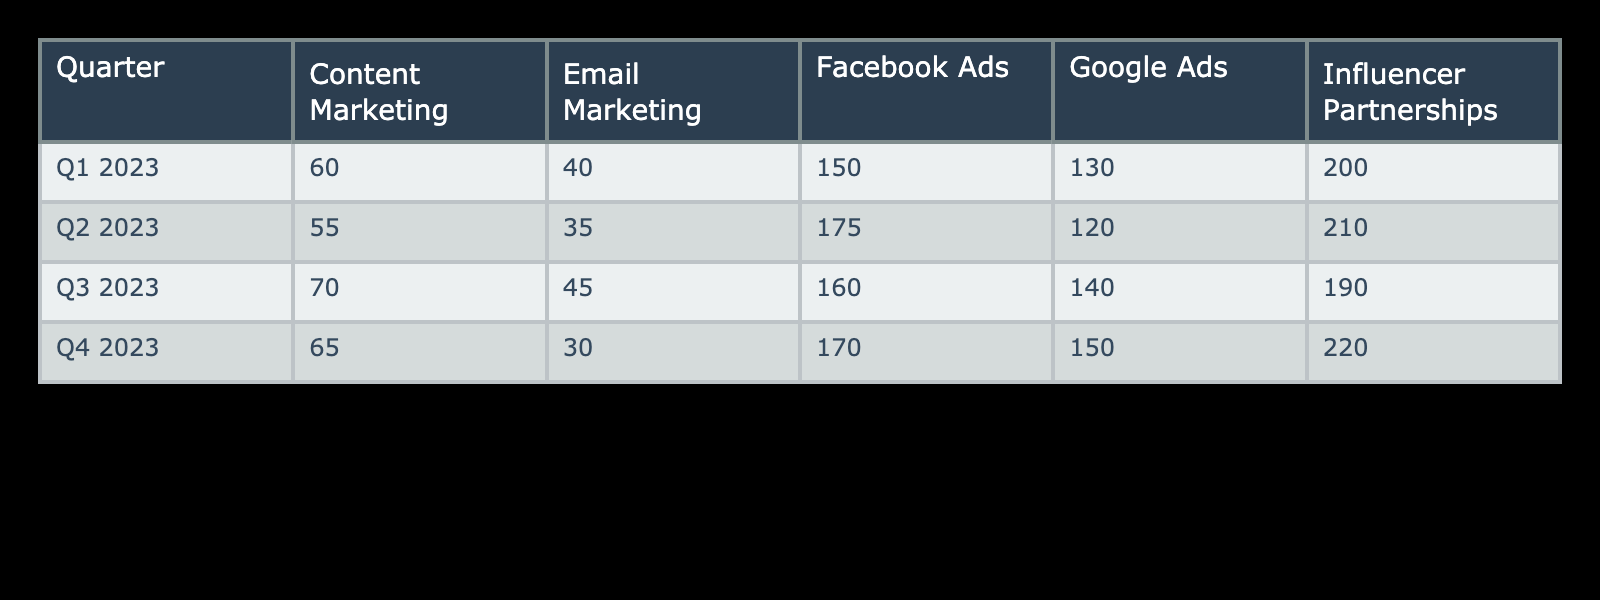What is the Customer Acquisition Cost for Google Ads in Q3 2023? In the table, I would look for the row corresponding to Q3 2023 and the column for Google Ads. The value listed there is 140.
Answer: 140 Which channel had the highest Customer Acquisition Cost in Q4 2023? I would find the row for Q4 2023 and scan through each channel to identify the maximum value. Influencer Partnerships has the highest CAC at 220.
Answer: Influencer Partnerships What is the total Customer Acquisition Cost for Email Marketing across all quarters? To find the total, I would sum the Customer Acquisition Cost for Email Marketing in each quarter: 40 (Q1) + 35 (Q2) + 45 (Q3) + 30 (Q4) = 150.
Answer: 150 Is the Customer Acquisition Cost for Content Marketing in Q2 higher than in Q1? I would compare the CAC values for Content Marketing in both quarters. Q2 is 55 and Q1 is 60, so Q2 is not higher.
Answer: No What is the average Customer Acquisition Cost for Facebook Ads over all four quarters? I would first find the CAC values for Facebook Ads in each quarter: 150 (Q1), 175 (Q2), 160 (Q3), and 170 (Q4). Then, I sum these values: 150 + 175 + 160 + 170 = 655. Finally, I divide by 4 to get the average: 655 / 4 = 163.75.
Answer: 163.75 Which quarter showed the largest increase in Customer Acquisition Cost for Influencer Partnerships compared to the previous quarter? I would analyze the CAC for Influencer Partnerships: Q1 is 200, Q2 is 210 (increase of 10), Q3 is 190 (decrease of 20), and Q4 is 220 (increase of 30). The largest increase is 30 from Q3 to Q4.
Answer: Q4 to Q3 What is the difference in Customer Acquisition Cost between Google Ads and Facebook Ads for Q1 2023? I look at Q1 2023: Google Ads has a CAC of 130, while Facebook Ads has a CAC of 150. So the difference is 150 - 130 = 20.
Answer: 20 In which quarter did Email Marketing achieve the lowest Customer Acquisition Cost? I would check the values for Email Marketing in each quarter: 40 (Q1), 35 (Q2), 45 (Q3), and 30 (Q4). The lowest value is in Q4 with 30.
Answer: Q4 Which channel had the lowest average Customer Acquisition Cost across the four quarters? I would calculate the average for each channel. For Email Marketing: (40 + 35 + 45 + 30) / 4 = 150 / 4 = 37.5; for Facebook Ads: (150 + 175 + 160 + 170) / 4 = 655 / 4 = 163.75; and for the others similarly. The averages will show that Email Marketing has the lowest CAC on average at 37.5.
Answer: Email Marketing 